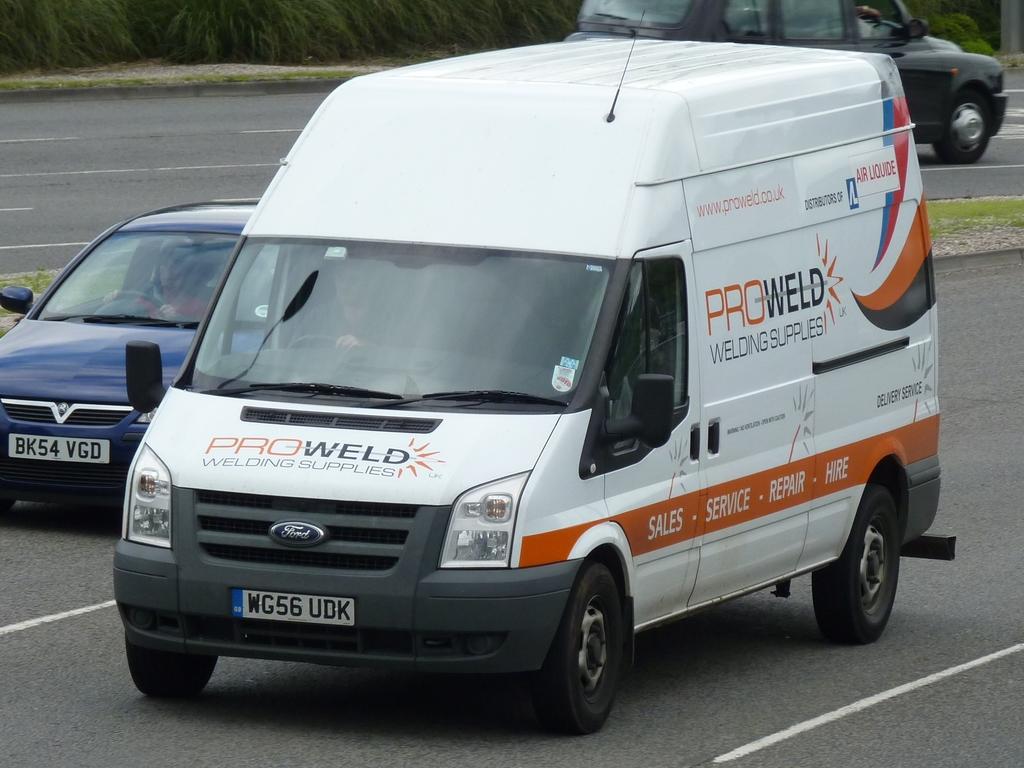What is the name of the company pictured on the van?
Keep it short and to the point. Proweld. What does the license plate on the white van say?
Ensure brevity in your answer.  Wg56 udk. 